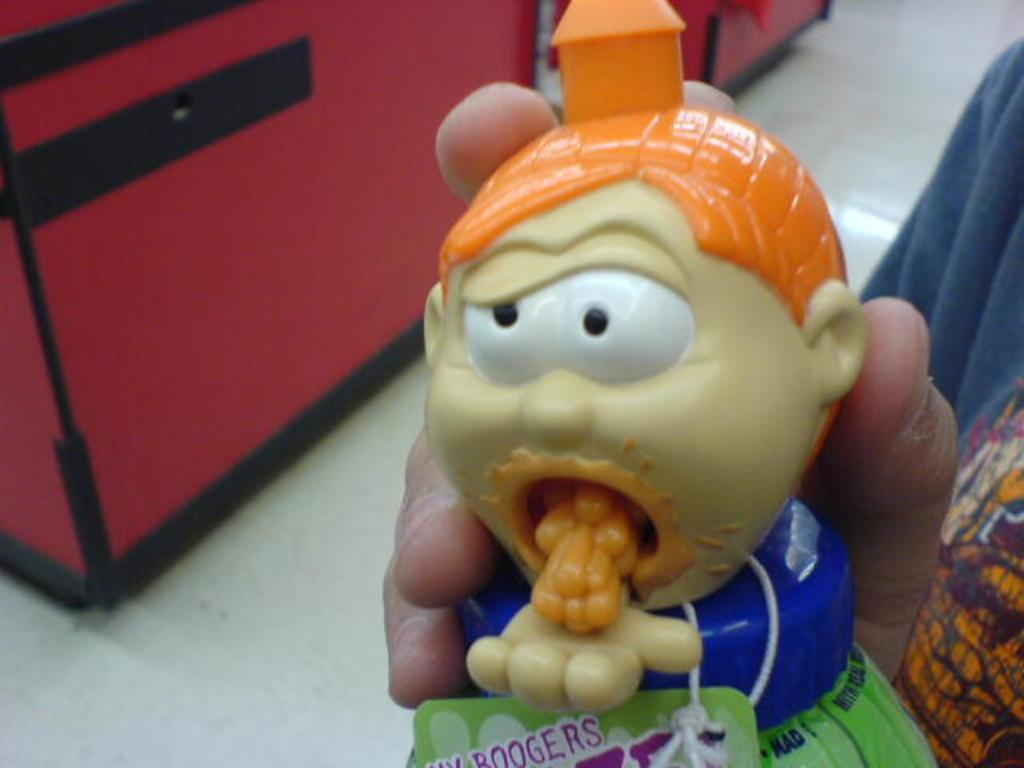What is the person in the image holding? The person is holding a toy in the image. Can you describe the toy's colors? The toy has orange and yellow colors. What else can be seen in the image besides the toy? There are two red color boxes in the image. Where are the boxes located? The boxes are placed on the floor. How does the person's cough affect the toy in the image? There is no mention of a cough in the image, so it cannot be determined how it would affect the toy. 